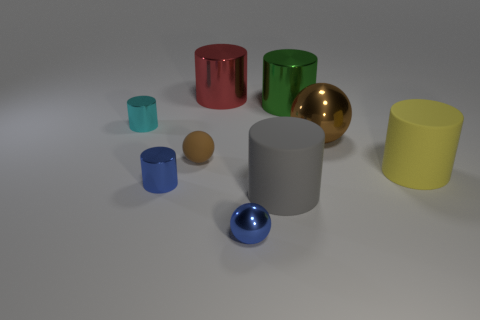The blue sphere that is made of the same material as the green cylinder is what size?
Keep it short and to the point. Small. How many large rubber cubes have the same color as the big ball?
Provide a short and direct response. 0. There is a rubber object that is to the left of the gray matte cylinder; is it the same size as the large yellow cylinder?
Offer a terse response. No. The tiny thing that is in front of the tiny matte object and on the right side of the tiny blue cylinder is what color?
Your answer should be compact. Blue. What number of objects are cyan metal cylinders or tiny cylinders that are in front of the small cyan object?
Provide a short and direct response. 2. What is the material of the tiny cylinder in front of the brown ball on the right side of the big metal thing that is to the left of the green shiny cylinder?
Give a very brief answer. Metal. Does the small cylinder in front of the big brown object have the same color as the small metallic sphere?
Your answer should be compact. Yes. How many blue objects are metallic objects or small cylinders?
Offer a terse response. 2. How many other objects are there of the same shape as the big gray matte thing?
Give a very brief answer. 5. Is the tiny brown thing made of the same material as the large green object?
Make the answer very short. No. 